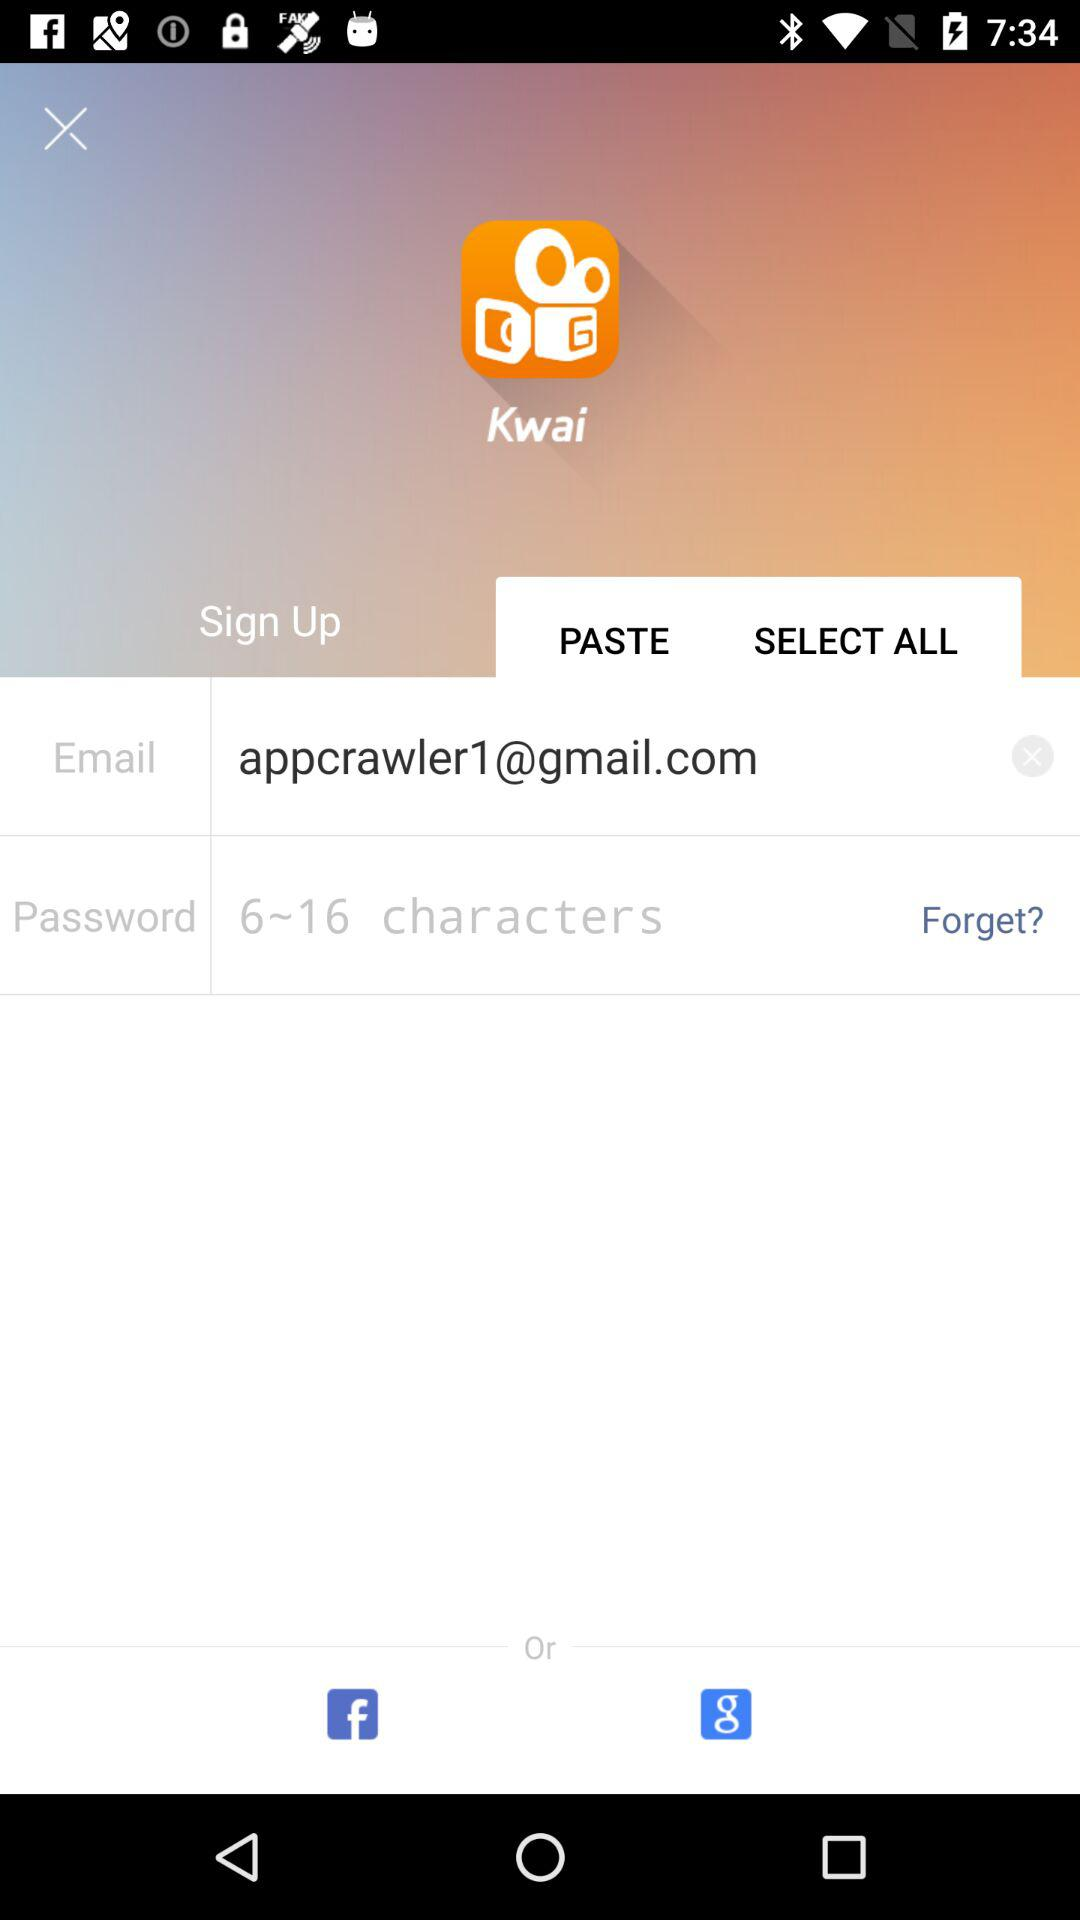How many characters can be used to set the password? The number of characters that can be used to set the password ranges from 6 to 16. 